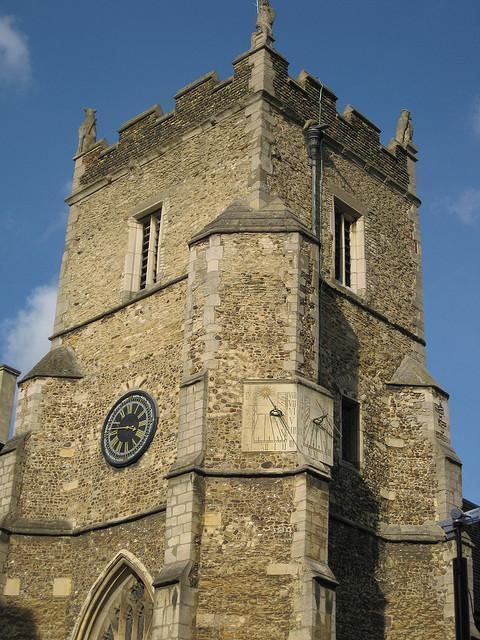How many windows are visible?
Give a very brief answer. 3. How many windows on this tower?
Give a very brief answer. 2. How many windows are above the clock?
Give a very brief answer. 1. How many people are wearing a safety vest in the image?
Give a very brief answer. 0. 